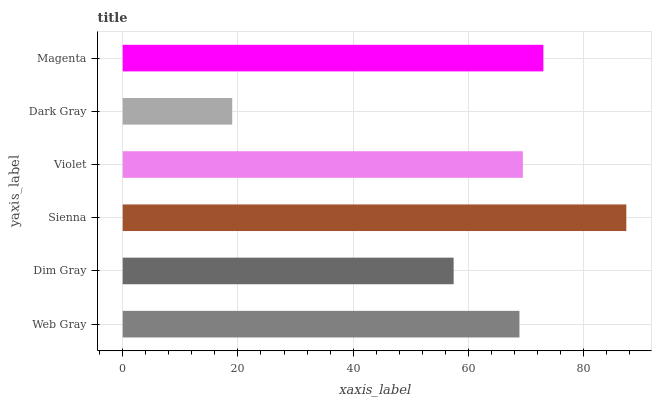Is Dark Gray the minimum?
Answer yes or no. Yes. Is Sienna the maximum?
Answer yes or no. Yes. Is Dim Gray the minimum?
Answer yes or no. No. Is Dim Gray the maximum?
Answer yes or no. No. Is Web Gray greater than Dim Gray?
Answer yes or no. Yes. Is Dim Gray less than Web Gray?
Answer yes or no. Yes. Is Dim Gray greater than Web Gray?
Answer yes or no. No. Is Web Gray less than Dim Gray?
Answer yes or no. No. Is Violet the high median?
Answer yes or no. Yes. Is Web Gray the low median?
Answer yes or no. Yes. Is Dark Gray the high median?
Answer yes or no. No. Is Sienna the low median?
Answer yes or no. No. 